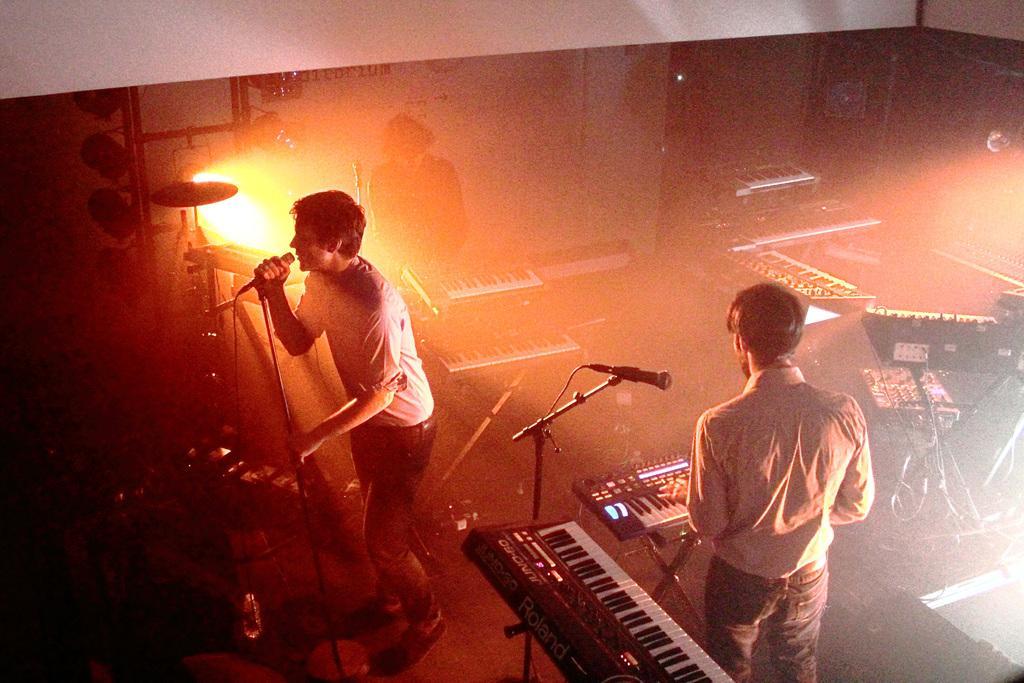Please provide a concise description of this image. In this picture I can see a man singing in the microphone, on the right side a man is playing the piano. In the background I can see the light. 